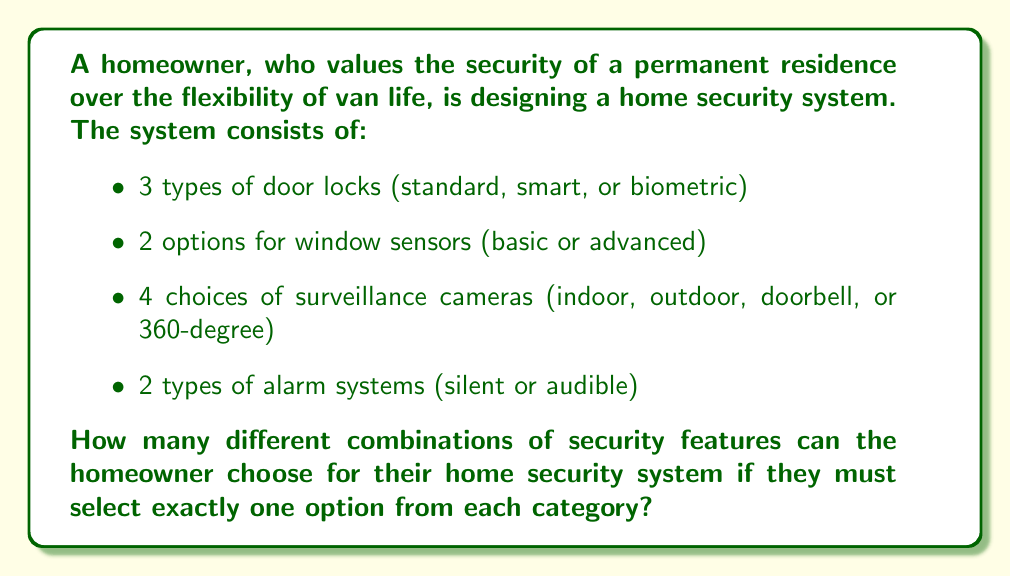Help me with this question. To solve this problem, we'll use the multiplication principle of combinatorics. This principle states that if we have a sequence of independent choices, the total number of possible outcomes is the product of the number of possibilities for each choice.

Let's break down the choices:
1. Door locks: 3 options
2. Window sensors: 2 options
3. Surveillance cameras: 4 options
4. Alarm systems: 2 options

Now, we multiply these numbers together:

$$ \text{Total combinations} = 3 \times 2 \times 4 \times 2 $$

$$ = 3 \times 2 \times 4 \times 2 $$
$$ = 6 \times 4 \times 2 $$
$$ = 24 \times 2 $$
$$ = 48 $$

Therefore, the homeowner has 48 different possible combinations to choose from when designing their home security system.
Answer: 48 combinations 